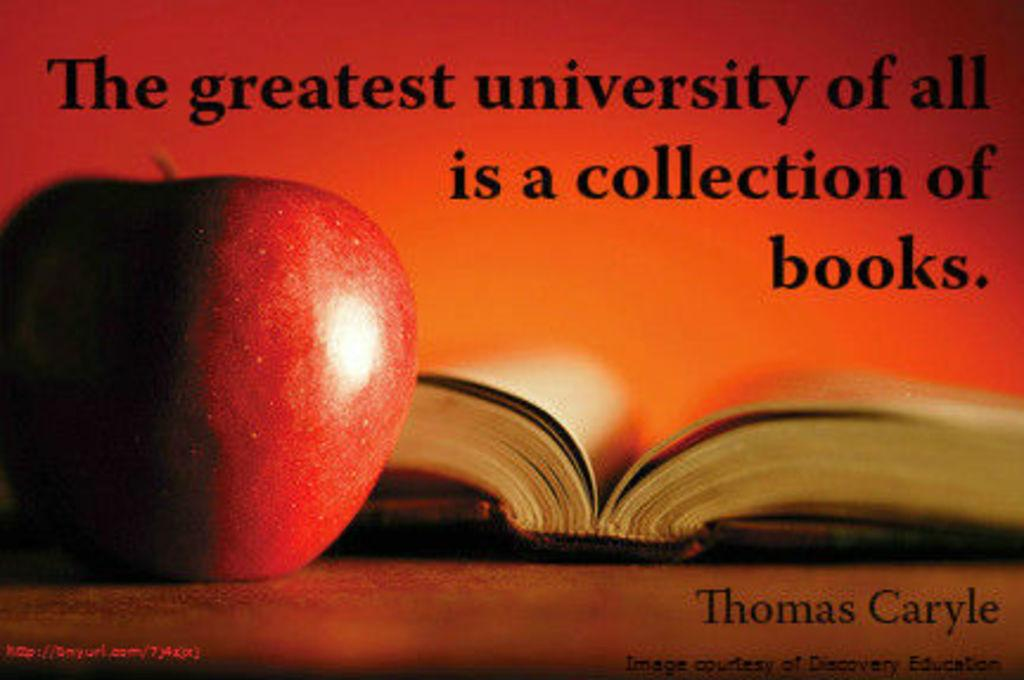<image>
Offer a succinct explanation of the picture presented. The greatest university of all is a collection of books by Thomas Caryle. 